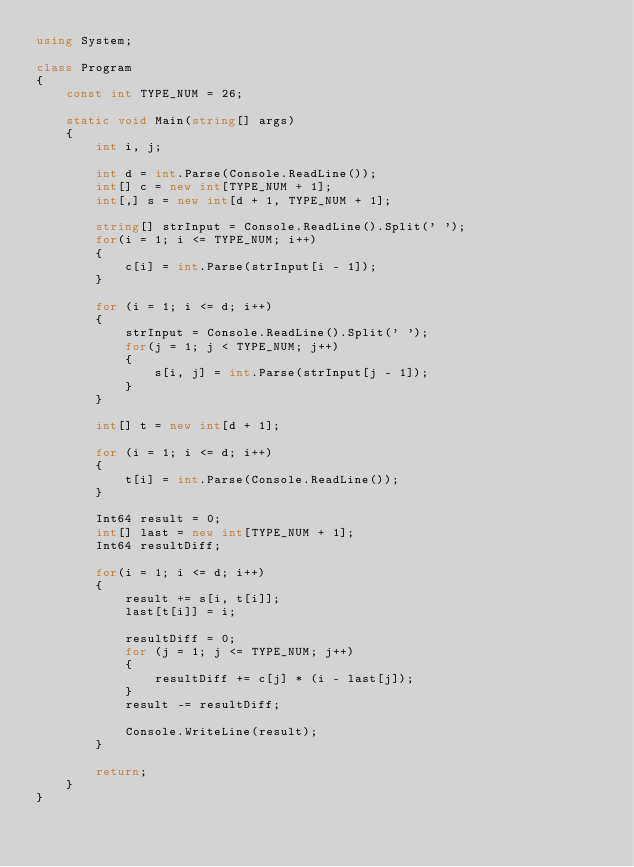<code> <loc_0><loc_0><loc_500><loc_500><_C#_>using System;

class Program
{
    const int TYPE_NUM = 26;

    static void Main(string[] args)
    {
        int i, j;

        int d = int.Parse(Console.ReadLine());
        int[] c = new int[TYPE_NUM + 1];
        int[,] s = new int[d + 1, TYPE_NUM + 1];

        string[] strInput = Console.ReadLine().Split(' ');
        for(i = 1; i <= TYPE_NUM; i++)
        {
            c[i] = int.Parse(strInput[i - 1]);
        }

        for (i = 1; i <= d; i++) 
        {
            strInput = Console.ReadLine().Split(' ');
            for(j = 1; j < TYPE_NUM; j++)
            {
                s[i, j] = int.Parse(strInput[j - 1]);
            }
        }

        int[] t = new int[d + 1];

        for (i = 1; i <= d; i++)
        {
            t[i] = int.Parse(Console.ReadLine());
        }

        Int64 result = 0;
        int[] last = new int[TYPE_NUM + 1];
        Int64 resultDiff;

        for(i = 1; i <= d; i++)
        {
            result += s[i, t[i]];
            last[t[i]] = i;

            resultDiff = 0;
            for (j = 1; j <= TYPE_NUM; j++)
            {
                resultDiff += c[j] * (i - last[j]);
            }
            result -= resultDiff;

            Console.WriteLine(result);
        }

        return;
    }
}</code> 